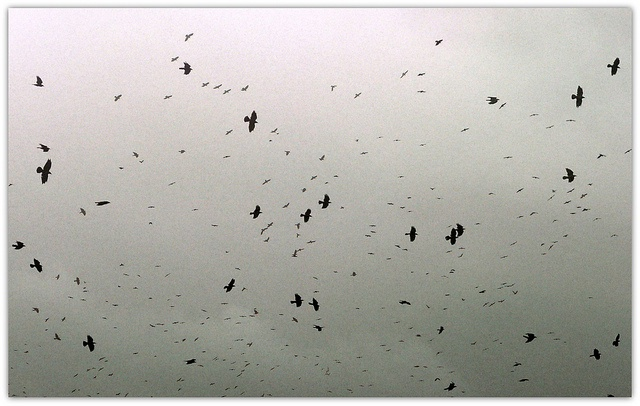Describe the objects in this image and their specific colors. I can see bird in white, darkgray, lightgray, and gray tones, bird in white, black, darkgray, gray, and lightgray tones, bird in white, black, and gray tones, bird in white, black, gray, and darkgray tones, and bird in white, black, darkgray, gray, and lightgray tones in this image. 